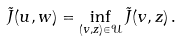<formula> <loc_0><loc_0><loc_500><loc_500>\tilde { J } ( u , w ) = \inf _ { ( v , z ) \in \mathcal { U } } \tilde { J } ( v , z ) \, .</formula> 